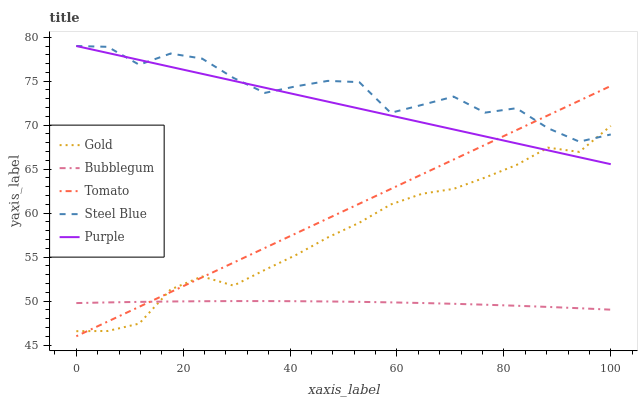Does Bubblegum have the minimum area under the curve?
Answer yes or no. Yes. Does Steel Blue have the maximum area under the curve?
Answer yes or no. Yes. Does Purple have the minimum area under the curve?
Answer yes or no. No. Does Purple have the maximum area under the curve?
Answer yes or no. No. Is Purple the smoothest?
Answer yes or no. Yes. Is Steel Blue the roughest?
Answer yes or no. Yes. Is Bubblegum the smoothest?
Answer yes or no. No. Is Bubblegum the roughest?
Answer yes or no. No. Does Tomato have the lowest value?
Answer yes or no. Yes. Does Purple have the lowest value?
Answer yes or no. No. Does Steel Blue have the highest value?
Answer yes or no. Yes. Does Bubblegum have the highest value?
Answer yes or no. No. Is Bubblegum less than Steel Blue?
Answer yes or no. Yes. Is Purple greater than Bubblegum?
Answer yes or no. Yes. Does Purple intersect Steel Blue?
Answer yes or no. Yes. Is Purple less than Steel Blue?
Answer yes or no. No. Is Purple greater than Steel Blue?
Answer yes or no. No. Does Bubblegum intersect Steel Blue?
Answer yes or no. No. 